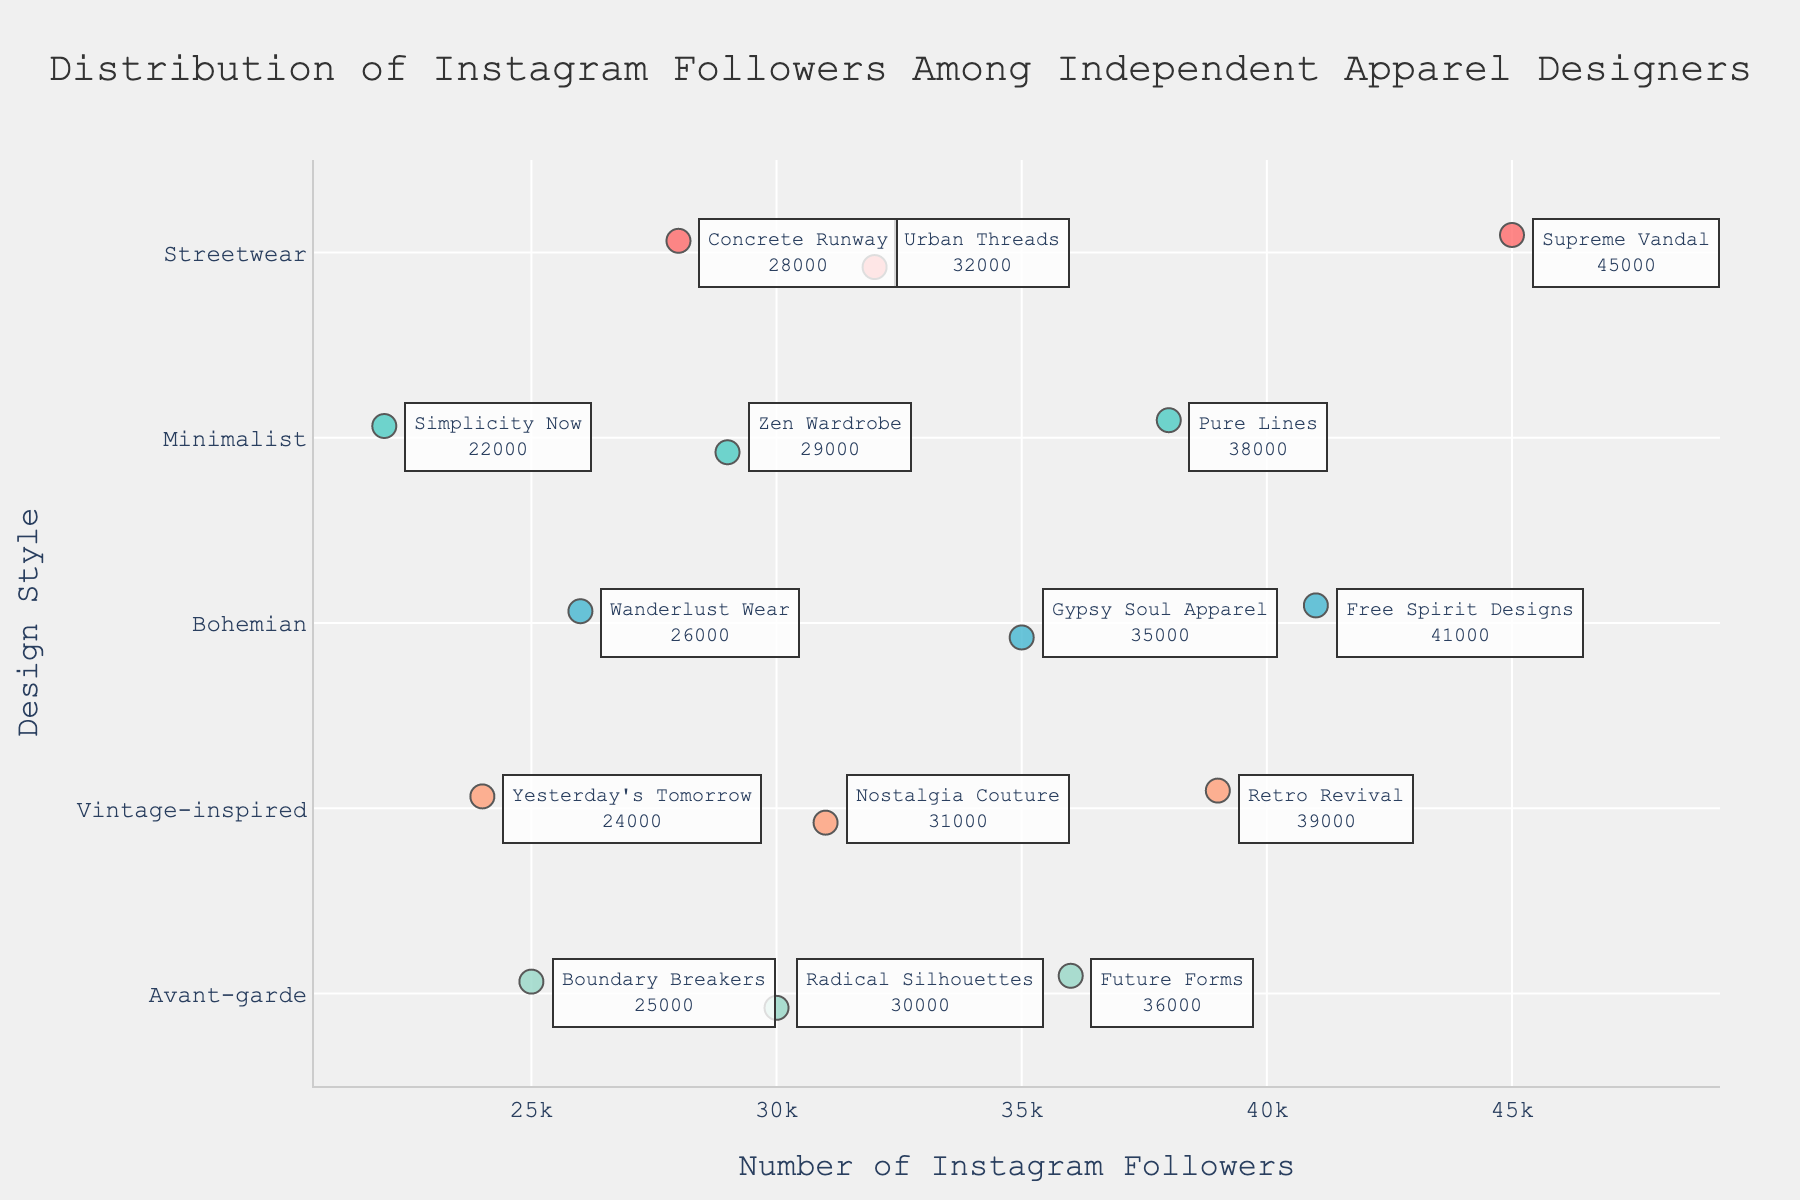What's the title of the figure? The title can be found at the top of the plot, it reads "Distribution of Instagram Followers Among Independent Apparel Designers." This title summarizes the content and the focus of the visual representation.
Answer: Distribution of Instagram Followers Among Independent Apparel Designers Which design style has the designer with the most followers? To find this, locate the data point with the highest number of followers on the x-axis and see which design style it belongs to; in this case, it's under Streetwear.
Answer: Streetwear How many followers does Retro Revival have? Look for the annotation associated with Retro Revival, where the number of followers is displayed directly next to the designer's name.
Answer: 39,000 What is the average number of followers for Minimalist designers? First, identify the data points for Minimalist designers, then sum their followers (38,000 + 29,000 + 22,000) which equals 89,000, and finally, divide by the number of designers 89,000 / 3 = 29,667.
Answer: 29,667 Which design style has the smallest range of followers? To find the range, calculate the difference between the highest and lowest follower counts in each design style. Minimalist has the smallest range (38,000 - 22,000) compared to other styles.
Answer: Minimalist Which design styles have more followers on average, Streetwear or Bohemian? First, calculate the average follower count for each style: Streetwear (45,000 + 32,000 + 28,000) / 3 = 35,000 and Bohemian (41,000 + 35,000 + 26,000) / 3 = 34,000. Compare the averages.
Answer: Streetwear Are there more designers in the Bohemian or Vintage-inspired category? Count the number of data points (designers) in each category; both have three designers each, so the answer is they are equal.
Answer: Equal Which Avant-garde designer has the fewest followers? Identify the data point under Avant-garde with the lowest follower count, which is Boundary Breakers with 25,000 followers.
Answer: Boundary Breakers What is the median number of followers for Vintage-inspired designers? Order the follower counts for Vintage-inspired designers: 24,000, 31,000, 39,000. The median is the middle value, which is 31,000.
Answer: 31,000 Which design style has the highest variance in followers? To determine variance, look at the spread and differences in follower counts within each style. Streetwear (45,000, 32,000, 28,000) shows a high variance compared to others.
Answer: Streetwear 